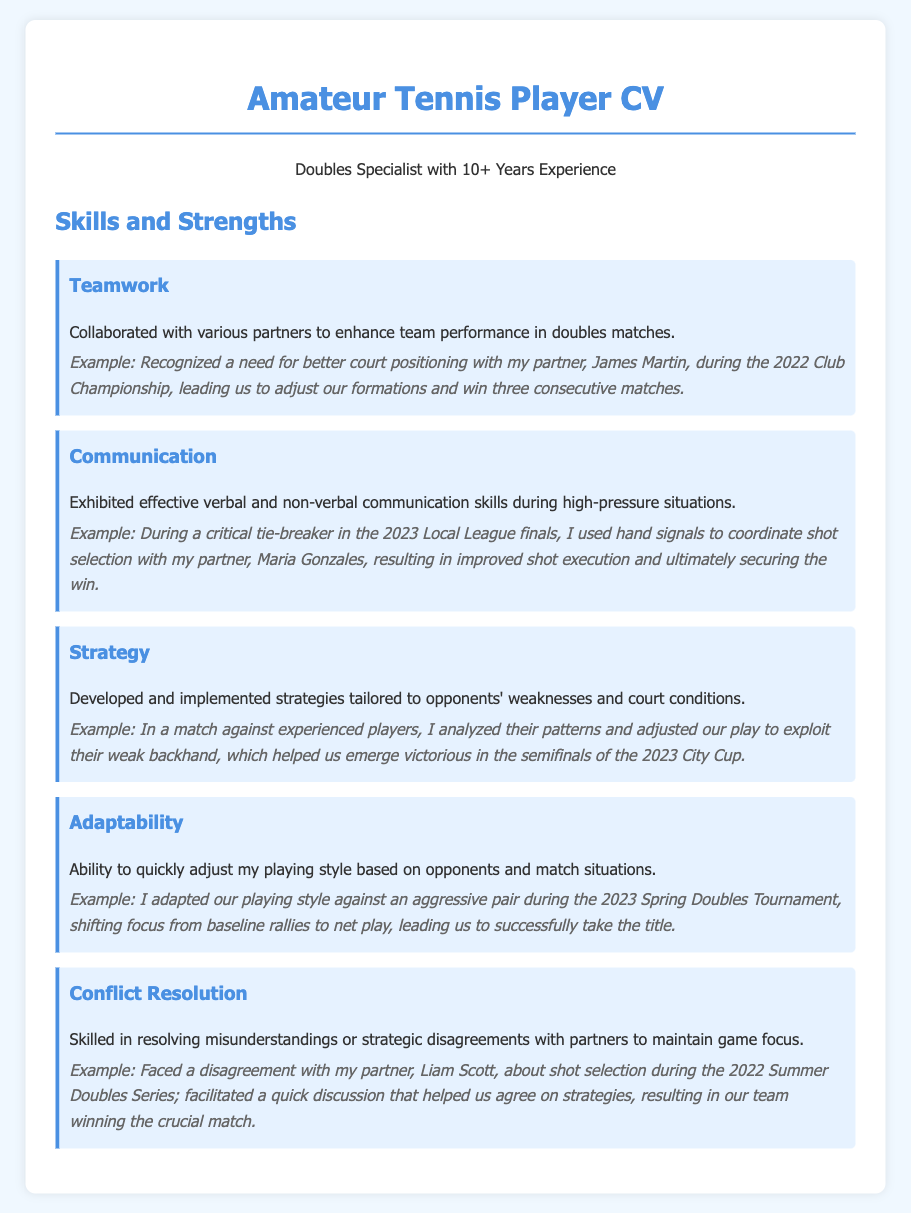what is the title of the document? The title of the document is found in the header section of the CV, which identifies the purpose of the document.
Answer: Amateur Tennis Player CV how many years of experience does the player have? The document states the player's experience in doubles play, providing a specific duration that showcases their background.
Answer: 10+ Years Experience who was the player's partner during the 2022 Club Championship? The player's partner is mentioned in the context of a notable match, providing insight into past collaborations.
Answer: James Martin what skill did the player demonstrate during the 2023 Local League finals? The skill is specifically highlighted in a context that reflects the player's effectiveness in high-pressure situations, showcasing communication skills.
Answer: Communication what strategy was used against experienced players in the semifinals of the 2023 City Cup? The strategy mentioned in the document reflects the player's tactical approach to challenging situations and opponents' weaknesses.
Answer: Exploit their weak backhand how did the player adapt their playing style in the 2023 Spring Doubles Tournament? The adaptation is described in a context that shows the player's ability to modify their tactics based on the opponents' play style.
Answer: Shifted focus from baseline rallies to net play what issue did the player resolve with their partner during the 2022 Summer Doubles Series? The document describes a specific conflict that arose during a match, showcasing the player's conflict resolution skills.
Answer: Shot selection 